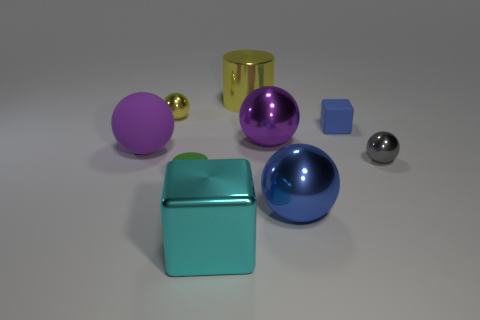Subtract all rubber balls. How many balls are left? 4 Subtract all gray balls. How many balls are left? 4 Subtract all cyan spheres. Subtract all cyan blocks. How many spheres are left? 5 Add 1 blocks. How many objects exist? 10 Subtract all balls. How many objects are left? 4 Add 2 big rubber things. How many big rubber things are left? 3 Add 5 small blue blocks. How many small blue blocks exist? 6 Subtract 1 green cylinders. How many objects are left? 8 Subtract all blue cylinders. Subtract all big shiny blocks. How many objects are left? 8 